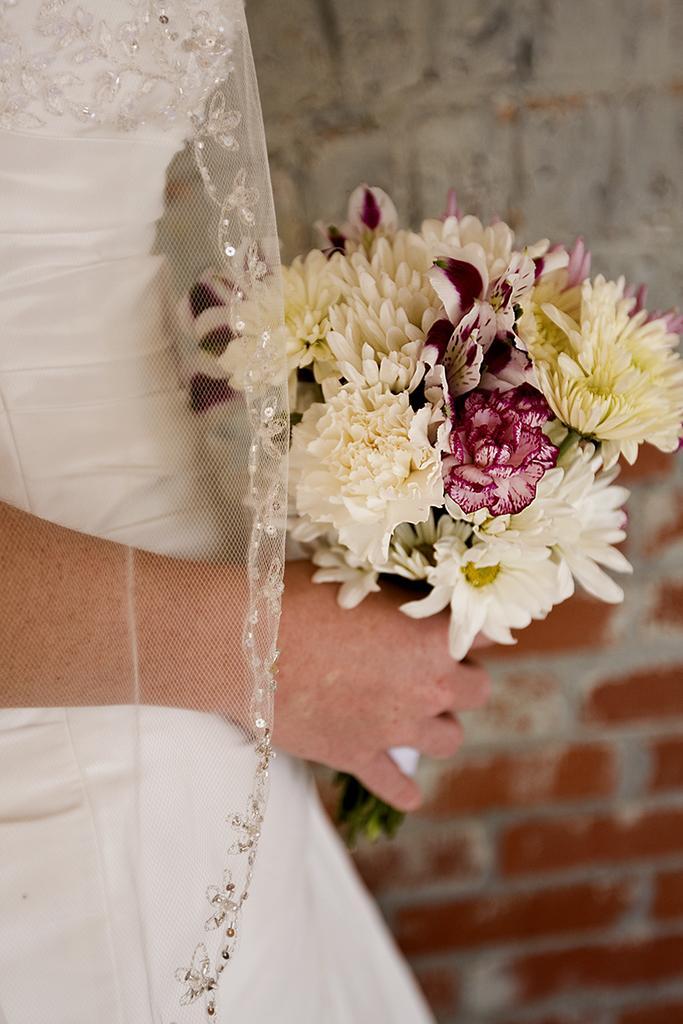In one or two sentences, can you explain what this image depicts? In this picture there is a person holding a flower bouquet in hand and in the background there is a wall. 